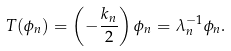Convert formula to latex. <formula><loc_0><loc_0><loc_500><loc_500>T ( \phi _ { n } ) = \left ( - \frac { k _ { n } } { 2 } \right ) \phi _ { n } = \lambda _ { n } ^ { - 1 } \phi _ { n } .</formula> 